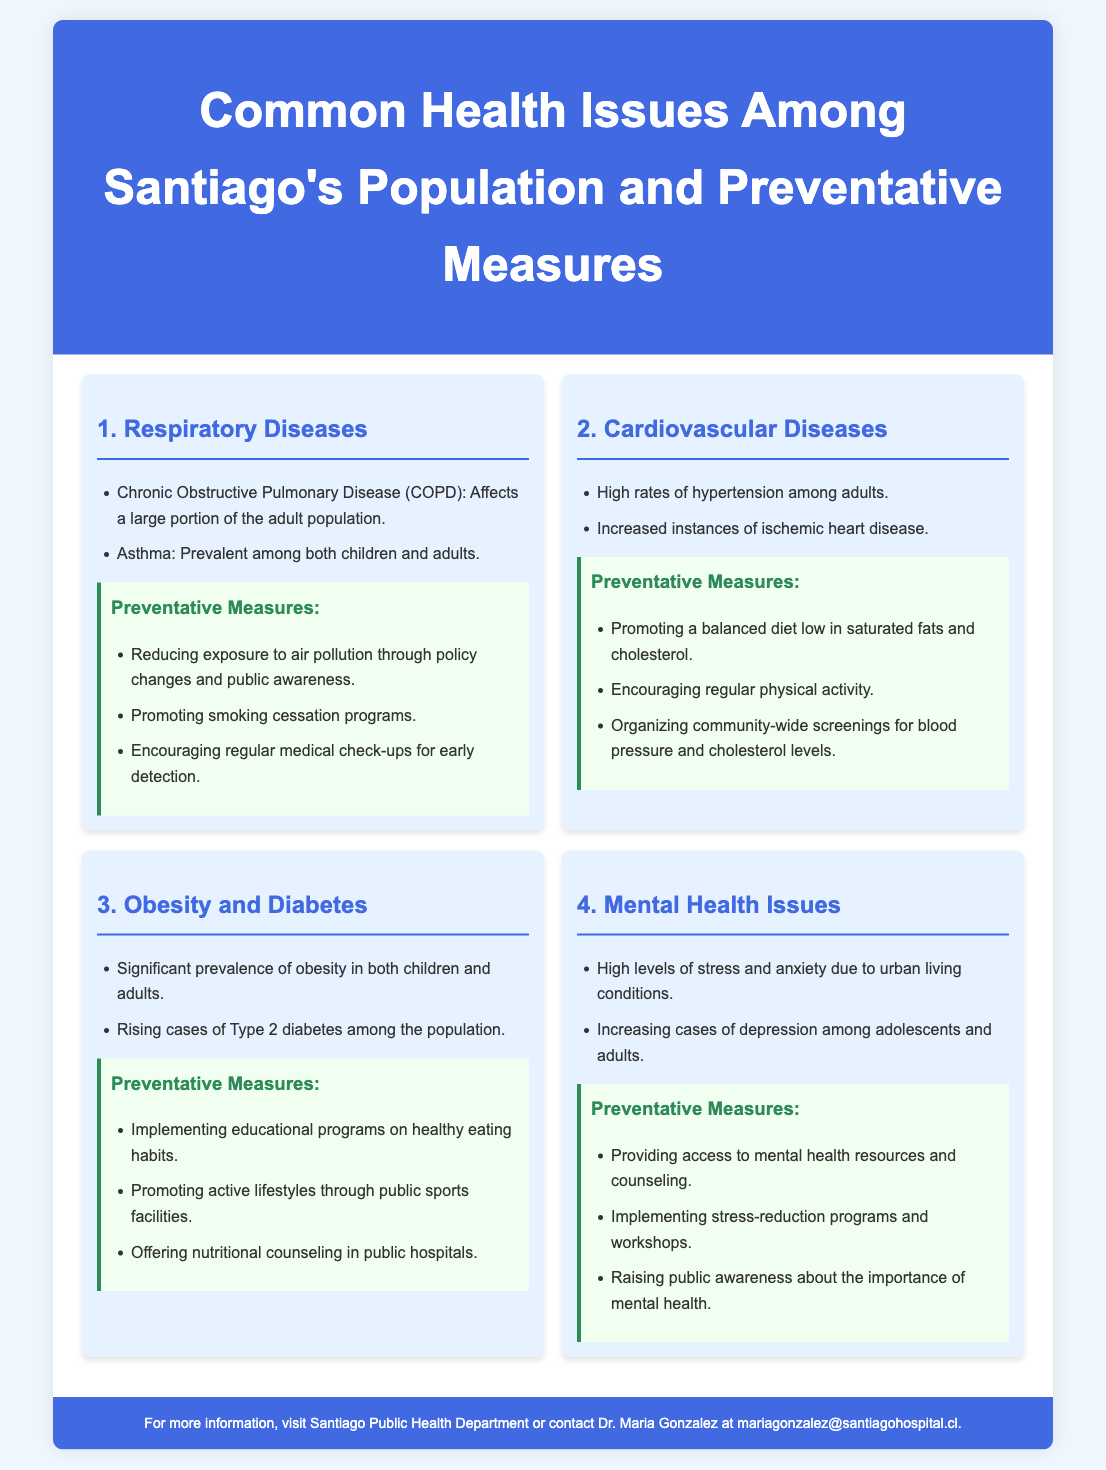What is the title of the infographic? The title is the main heading that describes the content of the document.
Answer: Common Health Issues Among Santiago's Population and Preventative Measures How many common health issues are identified in the infographic? The number of sections reflecting different health issues in the content.
Answer: Four What is one of the respiratory diseases mentioned? The question asks for specific diseases listed under the respiratory diseases section.
Answer: Asthma Which preventive measure is suggested for obesity and diabetes? The question seeks to identify a preventive measure related to obesity and diabetes.
Answer: Implementing educational programs on healthy eating habits What type of heart disease is mentioned as prevalent? This question looks for a specific term related to cardiovascular diseases noted in the document.
Answer: Ischemic heart disease What is a preventative measure for mental health issues? The question is focused on identifying a specific measure aimed at improving mental health.
Answer: Providing access to mental health resources and counseling What are the two main respiratory diseases listed? This question seeks to identify both diseases that fall under the respiratory illnesses.
Answer: Chronic Obstructive Pulmonary Disease (COPD) and Asthma Who is the contact person for more information? The answer requires finding a person mentioned in the footer for additional contact.
Answer: Dr. Maria Gonzalez What color is used for the header background? This question looks at the visual aspect of the infographic concerning color scheme.
Answer: Blue 